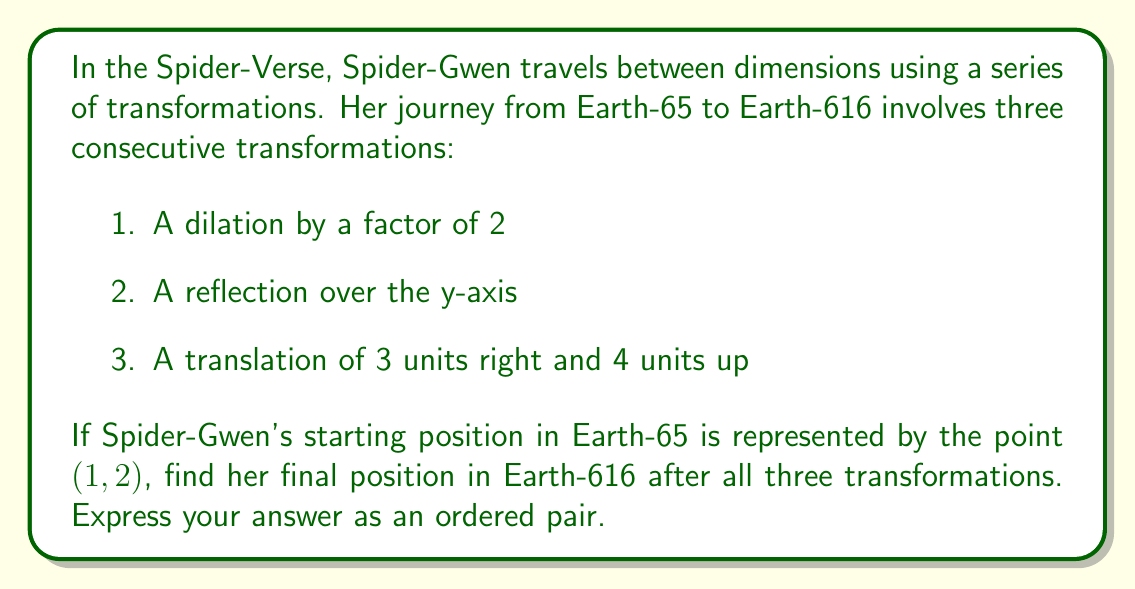Provide a solution to this math problem. Let's apply each transformation step-by-step:

1. Dilation by a factor of 2:
   This transformation multiplies both x and y coordinates by 2.
   $$(1, 2) \rightarrow (2 \cdot 1, 2 \cdot 2) = (2, 4)$$

2. Reflection over the y-axis:
   This transformation changes the sign of the x-coordinate.
   $$(2, 4) \rightarrow (-2, 4)$$

3. Translation of 3 units right and 4 units up:
   This transformation adds 3 to the x-coordinate and 4 to the y-coordinate.
   $$(-2, 4) \rightarrow (-2 + 3, 4 + 4) = (1, 8)$$

The composite transformation can be represented as a function composition:
$$f(x, y) = T_{3,4}(R_y(D_2(x, y)))$$
where $D_2$ is the dilation, $R_y$ is the reflection over the y-axis, and $T_{3,4}$ is the translation.

Applying this composite function to the initial point $(1, 2)$ gives us the final position $(1, 8)$.
Answer: $(1, 8)$ 